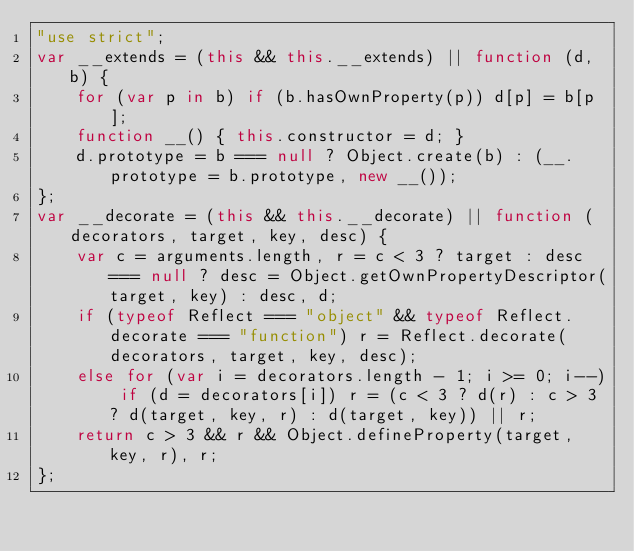<code> <loc_0><loc_0><loc_500><loc_500><_JavaScript_>"use strict";
var __extends = (this && this.__extends) || function (d, b) {
    for (var p in b) if (b.hasOwnProperty(p)) d[p] = b[p];
    function __() { this.constructor = d; }
    d.prototype = b === null ? Object.create(b) : (__.prototype = b.prototype, new __());
};
var __decorate = (this && this.__decorate) || function (decorators, target, key, desc) {
    var c = arguments.length, r = c < 3 ? target : desc === null ? desc = Object.getOwnPropertyDescriptor(target, key) : desc, d;
    if (typeof Reflect === "object" && typeof Reflect.decorate === "function") r = Reflect.decorate(decorators, target, key, desc);
    else for (var i = decorators.length - 1; i >= 0; i--) if (d = decorators[i]) r = (c < 3 ? d(r) : c > 3 ? d(target, key, r) : d(target, key)) || r;
    return c > 3 && r && Object.defineProperty(target, key, r), r;
};</code> 